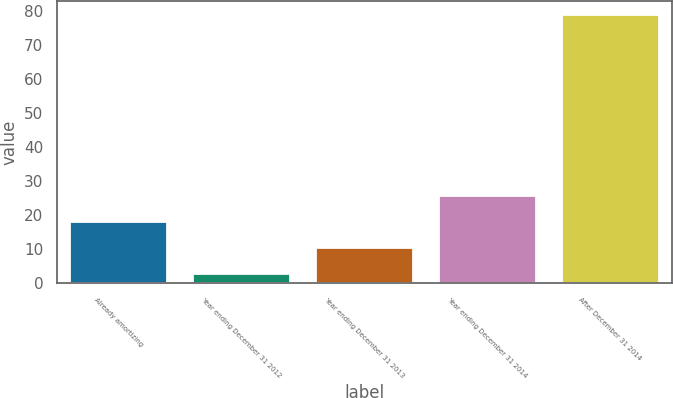Convert chart. <chart><loc_0><loc_0><loc_500><loc_500><bar_chart><fcel>Already amortizing<fcel>Year ending December 31 2012<fcel>Year ending December 31 2013<fcel>Year ending December 31 2014<fcel>After December 31 2014<nl><fcel>18.2<fcel>3<fcel>10.6<fcel>25.8<fcel>79<nl></chart> 